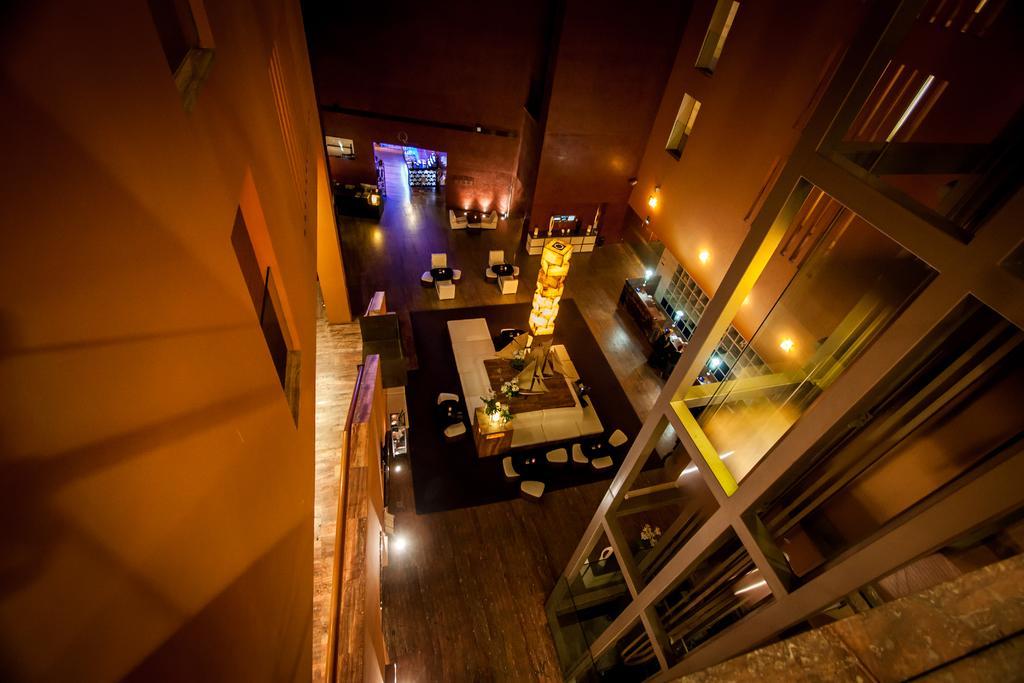Can you describe this image briefly? This is an inside view of a building. There are some lights. We can see a few chairs and tables on the floor. There are plants on a wooden desk. We can see some windows on the right and left side of the image. 